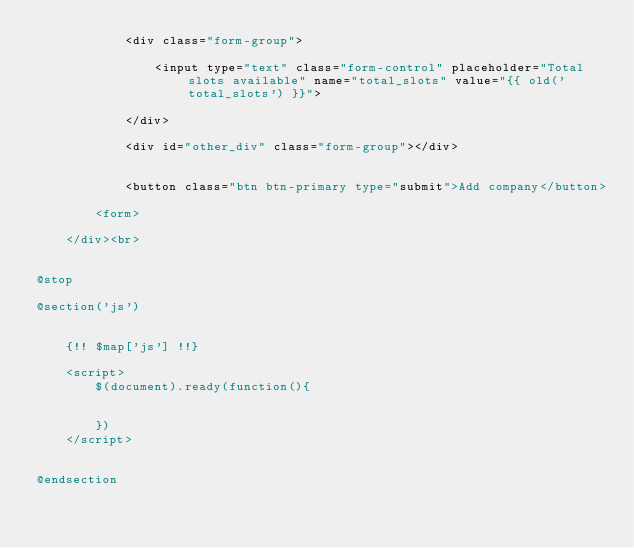Convert code to text. <code><loc_0><loc_0><loc_500><loc_500><_PHP_>            <div class="form-group">

                <input type="text" class="form-control" placeholder="Total slots available" name="total_slots" value="{{ old('total_slots') }}">

            </div>

            <div id="other_div" class="form-group"></div>


            <button class="btn btn-primary type="submit">Add company</button>

        <form>

    </div><br>


@stop

@section('js')


    {!! $map['js'] !!}  

    <script>
        $(document).ready(function(){

            
        })
    </script>

    
@endsection</code> 